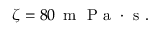Convert formula to latex. <formula><loc_0><loc_0><loc_500><loc_500>\zeta = 8 0 \, m P a \cdot s .</formula> 